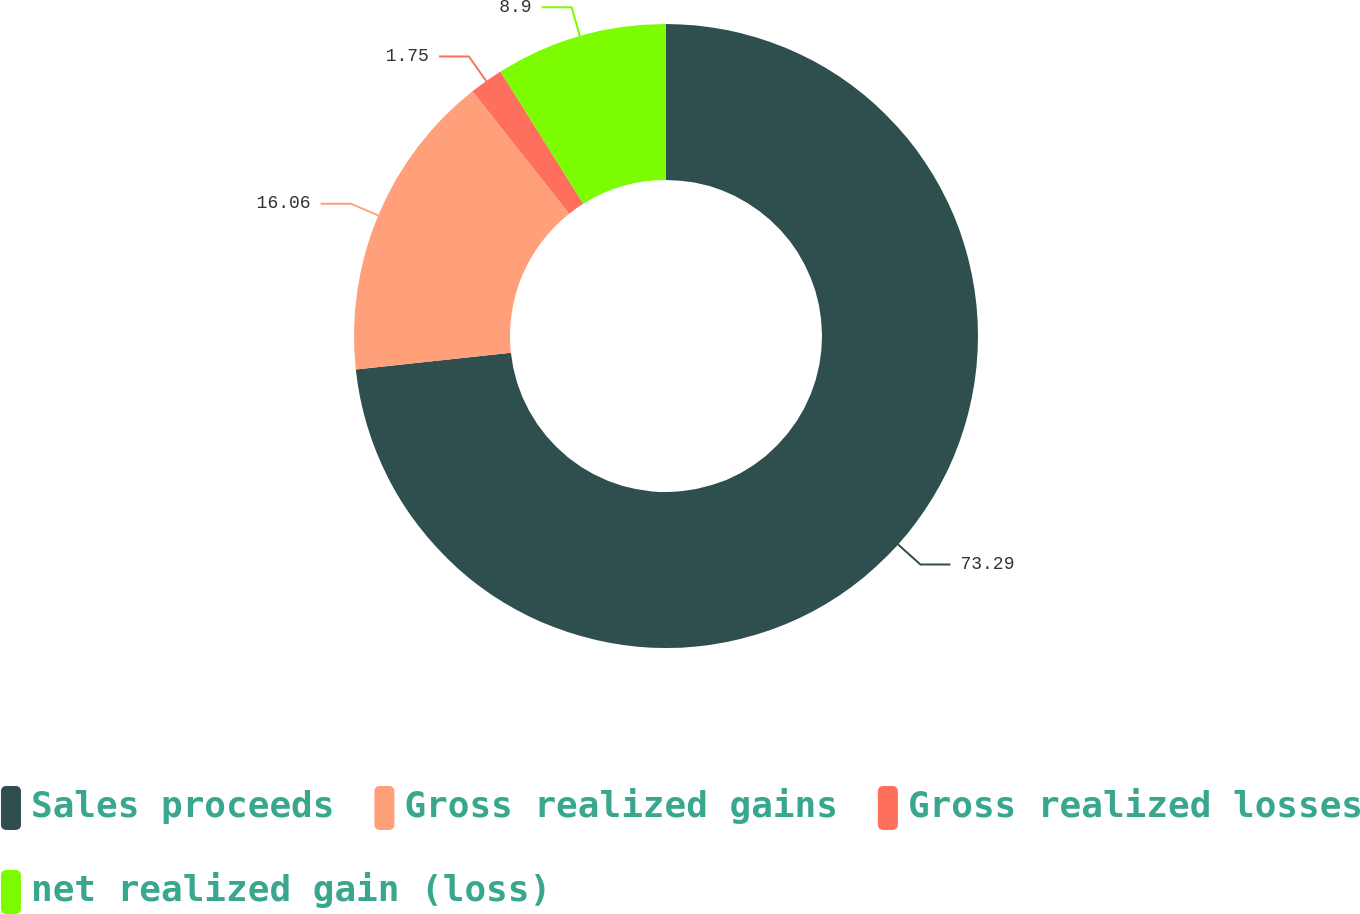<chart> <loc_0><loc_0><loc_500><loc_500><pie_chart><fcel>Sales proceeds<fcel>Gross realized gains<fcel>Gross realized losses<fcel>net realized gain (loss)<nl><fcel>73.3%<fcel>16.06%<fcel>1.75%<fcel>8.9%<nl></chart> 